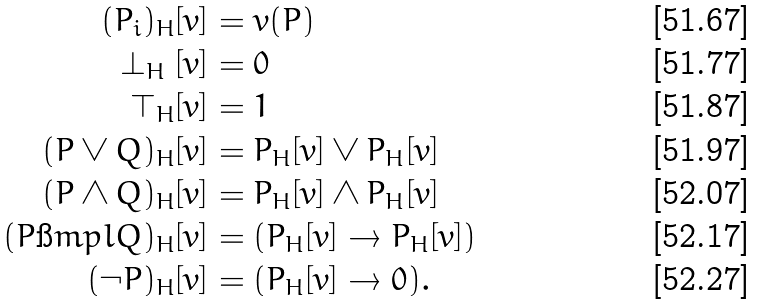Convert formula to latex. <formula><loc_0><loc_0><loc_500><loc_500>( P _ { i } ) _ { H } [ v ] & = v ( P ) \\ \perp _ { H } [ v ] & = 0 \\ \top _ { H } [ v ] & = 1 \\ ( P \lor Q ) _ { H } [ v ] & = P _ { H } [ v ] \lor P _ { H } [ v ] \\ ( P \land Q ) _ { H } [ v ] & = P _ { H } [ v ] \land P _ { H } [ v ] \\ ( P \i m p l Q ) _ { H } [ v ] & = ( P _ { H } [ v ] \rightarrow P _ { H } [ v ] ) \\ ( \neg P ) _ { H } [ v ] & = ( P _ { H } [ v ] \rightarrow 0 ) .</formula> 